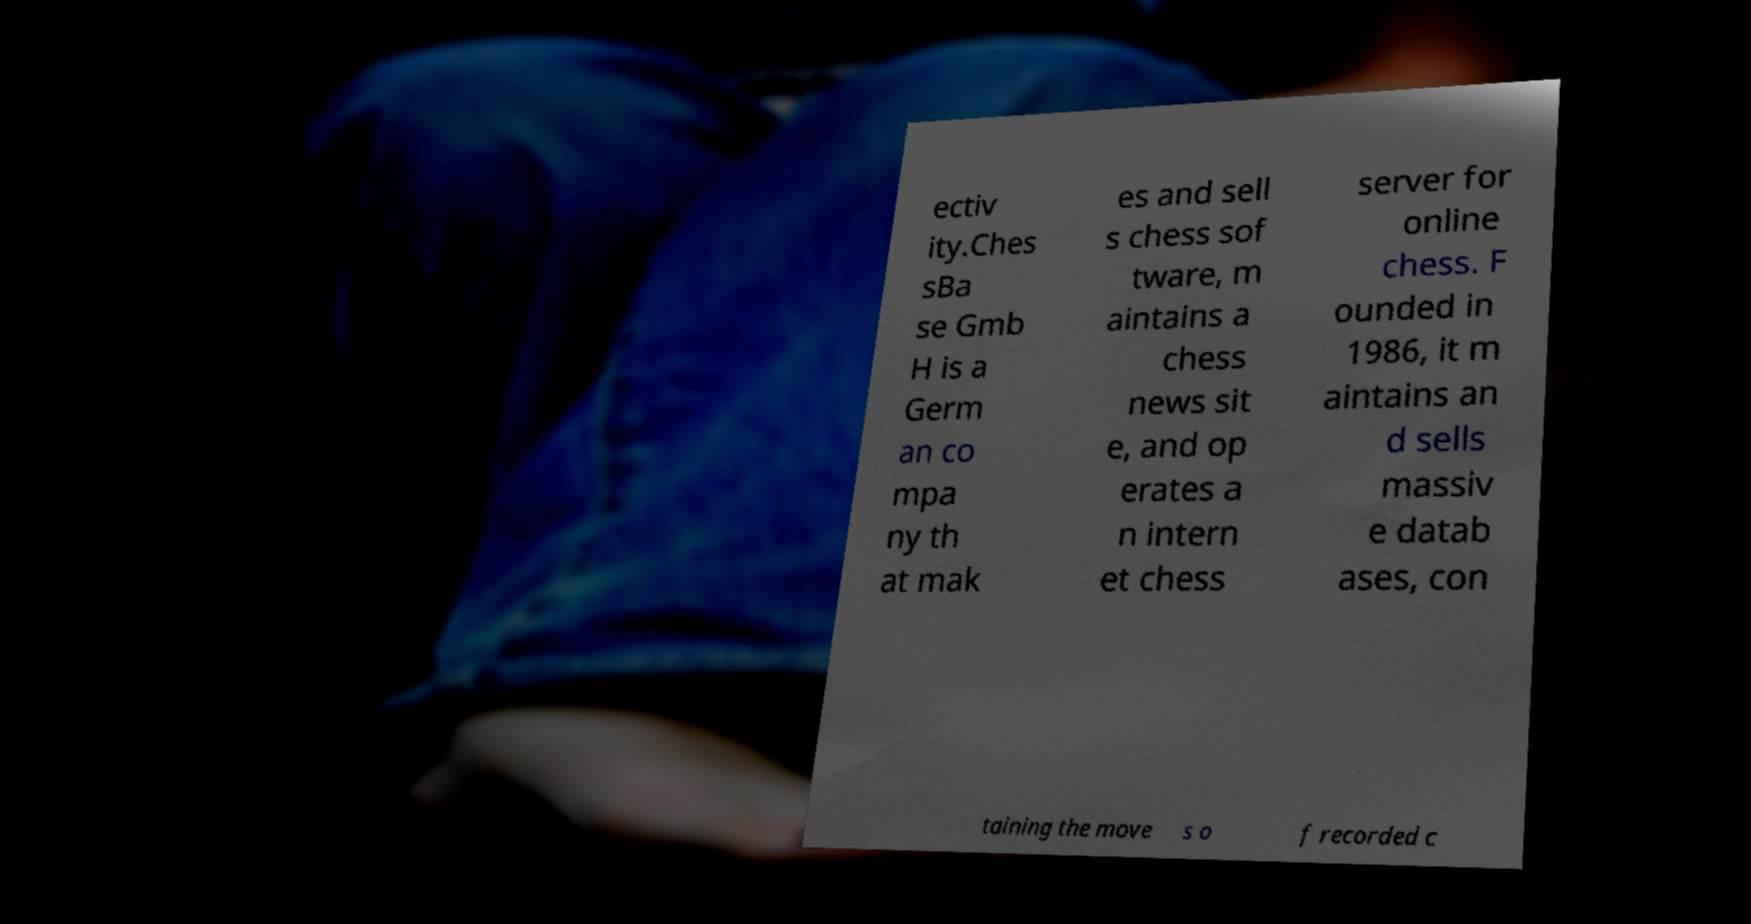What messages or text are displayed in this image? I need them in a readable, typed format. ectiv ity.Ches sBa se Gmb H is a Germ an co mpa ny th at mak es and sell s chess sof tware, m aintains a chess news sit e, and op erates a n intern et chess server for online chess. F ounded in 1986, it m aintains an d sells massiv e datab ases, con taining the move s o f recorded c 